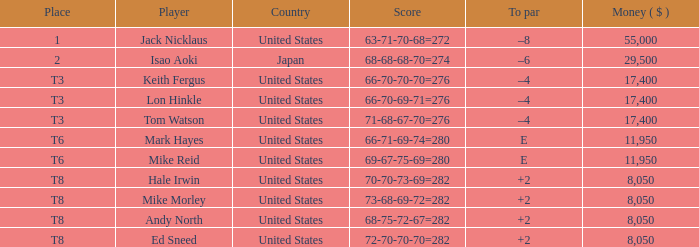What competitor possesses an amount exceeding 11,950, positioned in t8, and has a score of 73-68-69-72=282? None. 